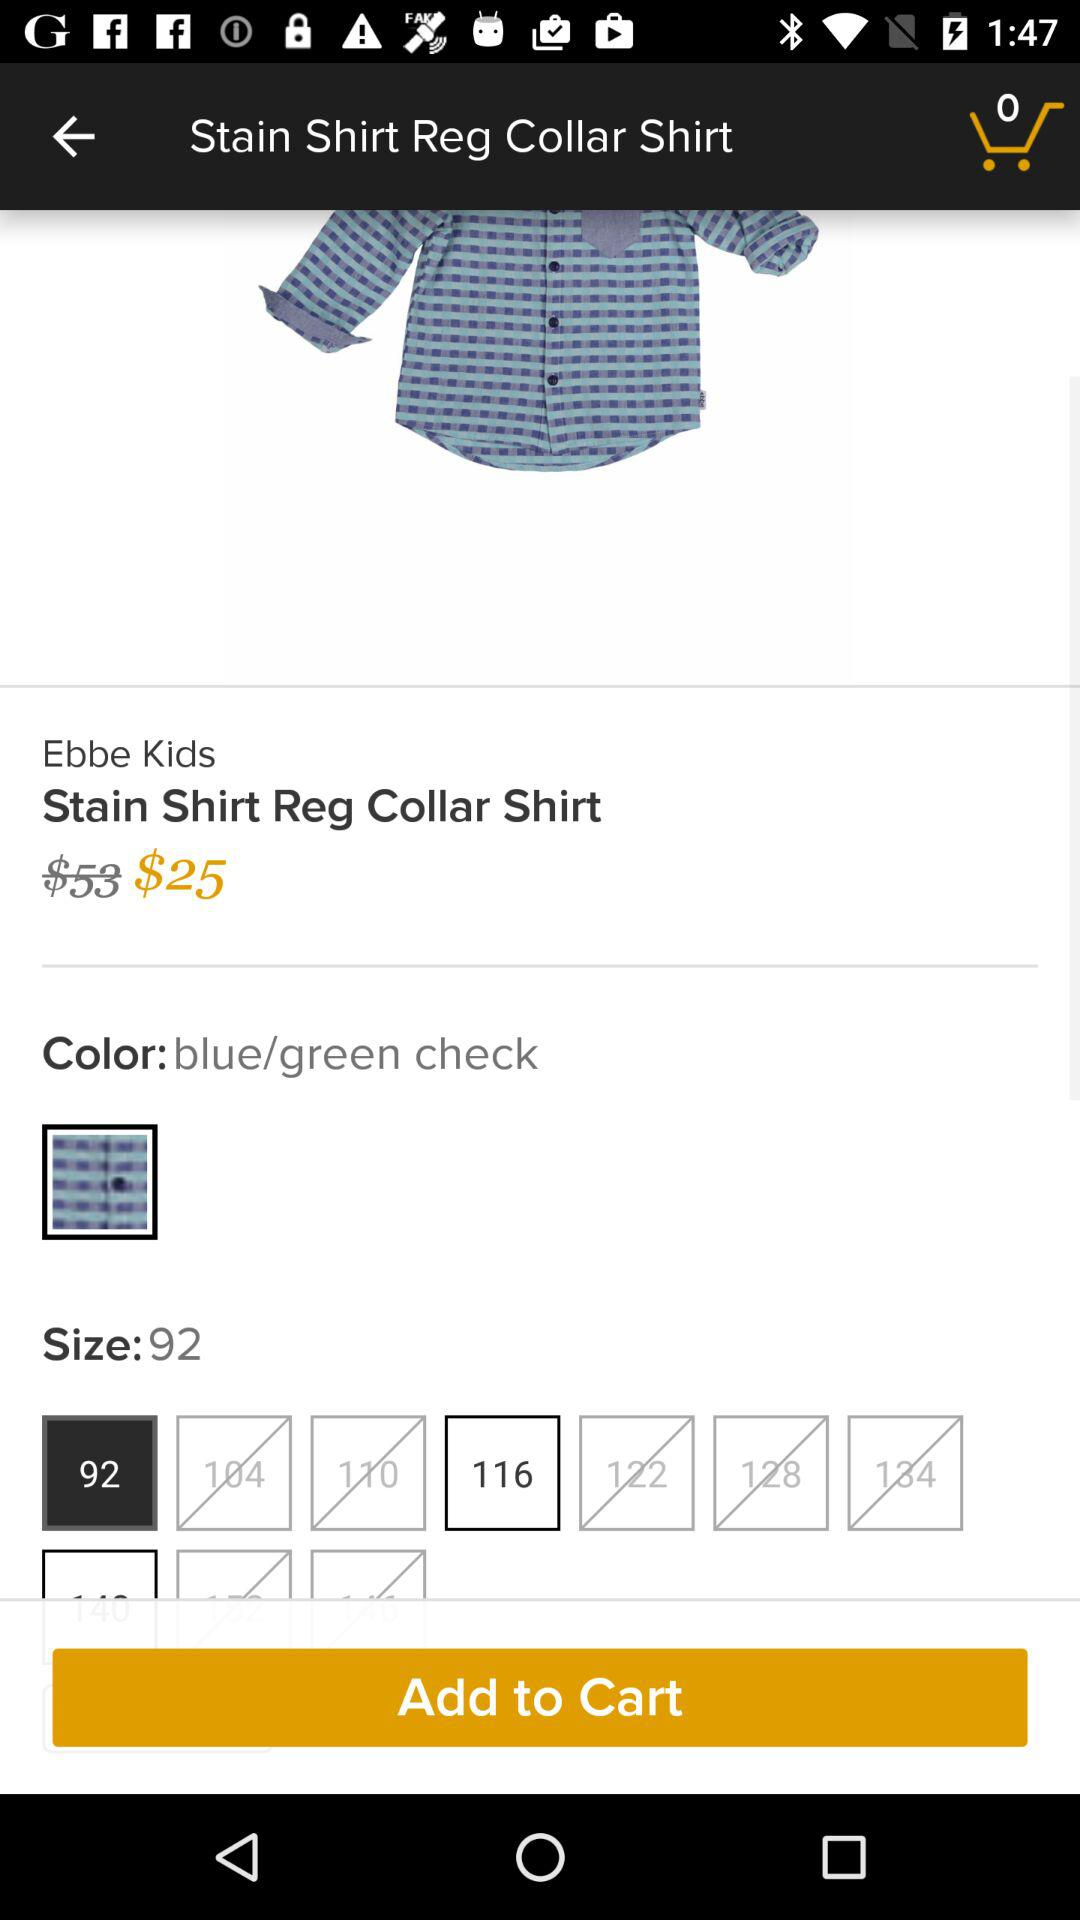How many colors are available? The colors are available in "blue/green check". 